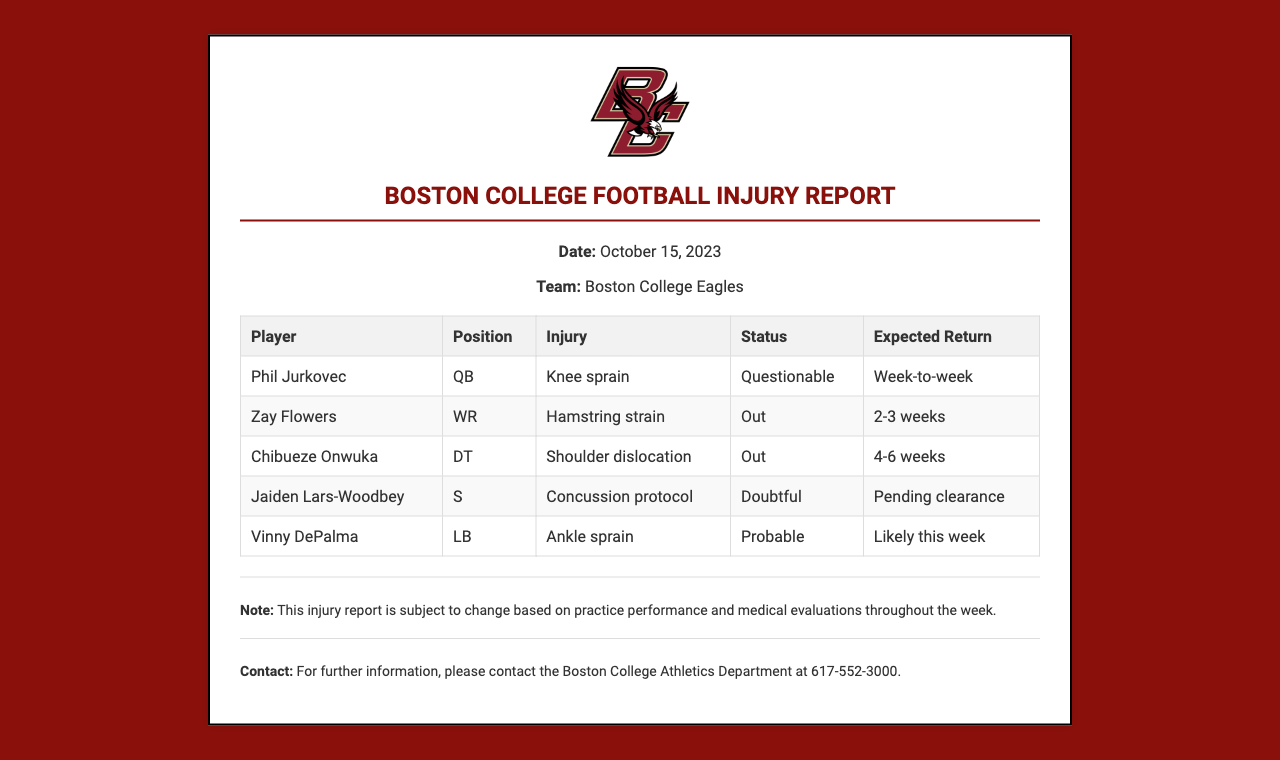What is the date of the injury report? The date of the injury report is stated in the header section of the document.
Answer: October 15, 2023 Who is the player with a knee sprain? The document lists the player's name, position, and injury in the table.
Answer: Phil Jurkovec What is the expected return time for Zay Flowers? The expected return for the player is mentioned under the 'Expected Return' column.
Answer: 2-3 weeks What is Vinny DePalma's injury status? This information is found in the table under the 'Status' column for the player.
Answer: Probable How long is Chibueze Onwuka expected to be out? The duration for which the player is expected to be out is specified in the 'Expected Return' column.
Answer: 4-6 weeks Which player is in concussion protocol? The player's name can be found under the 'Injury' column in the table.
Answer: Jaiden Lars-Woodbey What is the overall note regarding the injury report? The note is provided at the bottom of the document, clarifying the subject to change.
Answer: Subject to change Who should be contacted for further information? The document specifies who to contact in the 'Contact' section.
Answer: Boston College Athletics Department 